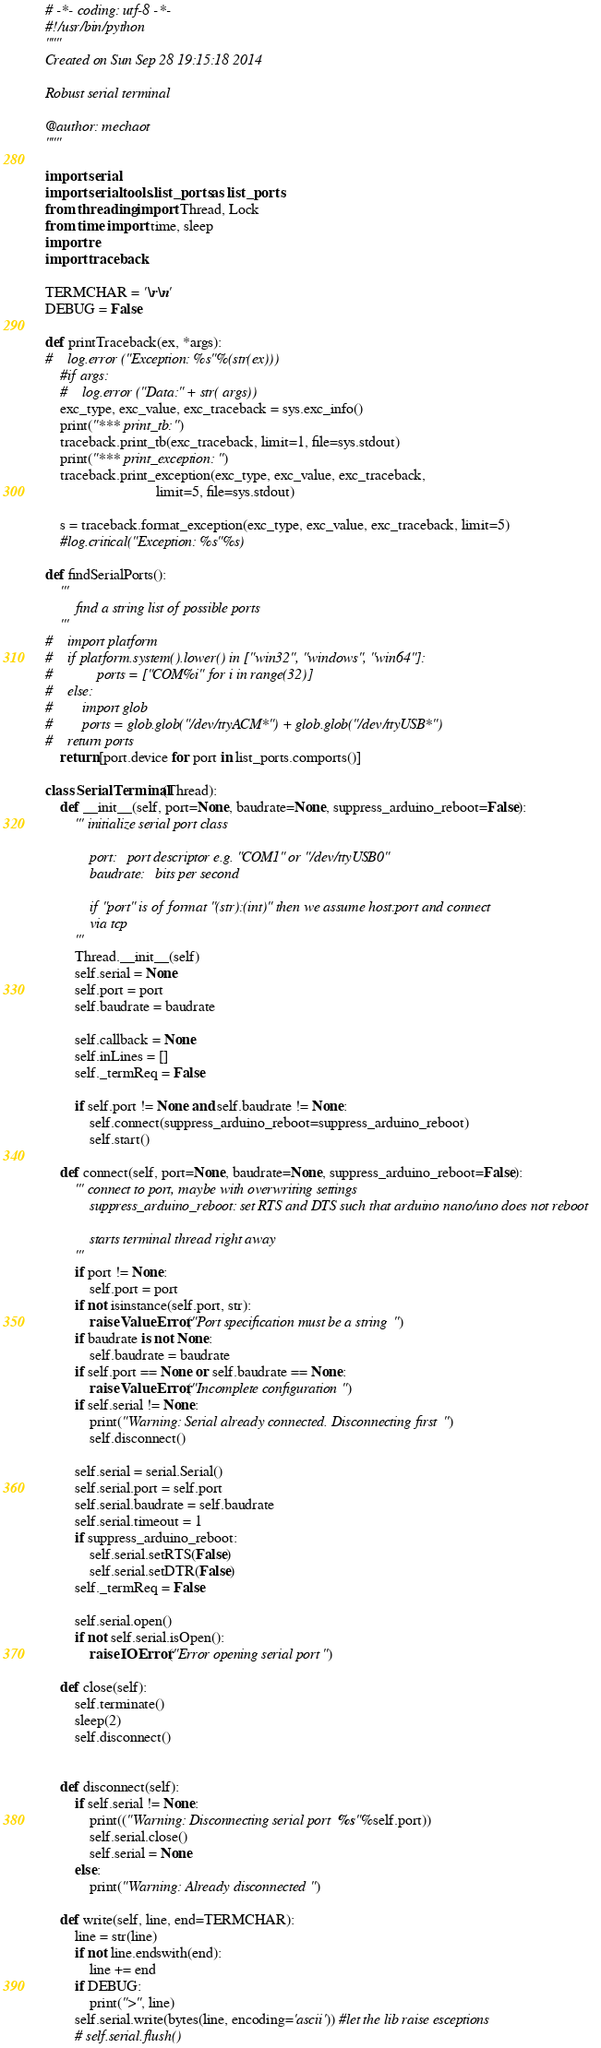Convert code to text. <code><loc_0><loc_0><loc_500><loc_500><_Python_># -*- coding: utf-8 -*-
#!/usr/bin/python
"""
Created on Sun Sep 28 19:15:18 2014

Robust serial terminal

@author: mechaot
"""

import serial
import serial.tools.list_ports as list_ports
from threading import Thread, Lock
from time import time, sleep
import re
import traceback

TERMCHAR = '\r\n'
DEBUG = False

def printTraceback(ex, *args):
#    log.error ("Exception: %s"%(str(ex)))
    #if args:
    #    log.error ("Data:" + str( args))
    exc_type, exc_value, exc_traceback = sys.exc_info()
    print("*** print_tb:")
    traceback.print_tb(exc_traceback, limit=1, file=sys.stdout)
    print("*** print_exception:")
    traceback.print_exception(exc_type, exc_value, exc_traceback,
                              limit=5, file=sys.stdout)

    s = traceback.format_exception(exc_type, exc_value, exc_traceback, limit=5)
    #log.critical("Exception: %s"%s)
    
def findSerialPorts():
    '''
        find a string list of possible ports
    '''
#    import platform
#    if platform.system().lower() in ["win32", "windows", "win64"]:
#            ports = ["COM%i" for i in range(32)]
#    else:
#        import glob
#        ports = glob.glob("/dev/ttyACM*") + glob.glob("/dev/ttyUSB*")
#    return ports
    return [port.device for port in list_ports.comports()]

class SerialTerminal(Thread):
    def __init__(self, port=None, baudrate=None, suppress_arduino_reboot=False):
        ''' initialize serial port class
        
            port:   port descriptor e.g. "COM1" or "/dev/ttyUSB0"
            baudrate:   bits per second

            if "port" is of format "(str):(int)" then we assume host:port and connect
            via tcp
        '''
        Thread.__init__(self)
        self.serial = None
        self.port = port
        self.baudrate = baudrate

        self.callback = None
        self.inLines = []
        self._termReq = False                
                
        if self.port != None and self.baudrate != None:
            self.connect(suppress_arduino_reboot=suppress_arduino_reboot)
            self.start()
        
    def connect(self, port=None, baudrate=None, suppress_arduino_reboot=False):
        ''' connect to port, maybe with overwriting settings
            suppress_arduino_reboot: set RTS and DTS such that arduino nano/uno does not reboot
            
            starts terminal thread right away
        '''
        if port != None:
            self.port = port
        if not isinstance(self.port, str):
            raise ValueError("Port specification must be a string")
        if baudrate is not None:
            self.baudrate = baudrate
        if self.port == None or self.baudrate == None:
            raise ValueError("Incomplete configuration")
        if self.serial != None:
            print("Warning: Serial already connected. Disconnecting first")
            self.disconnect()
                        
        self.serial = serial.Serial()            
        self.serial.port = self.port
        self.serial.baudrate = self.baudrate
        self.serial.timeout = 1
        if suppress_arduino_reboot:
            self.serial.setRTS(False)
            self.serial.setDTR(False)
        self._termReq = False
        
        self.serial.open()
        if not self.serial.isOpen():
            raise IOError("Error opening serial port")
        
    def close(self):
        self.terminate()
        sleep(2)
        self.disconnect()

        
    def disconnect(self):
        if self.serial != None:
            print(("Warning: Disconnecting serial port %s"%self.port))            
            self.serial.close()
            self.serial = None            
        else:
            print("Warning: Already disconnected")            
            
    def write(self, line, end=TERMCHAR):
        line = str(line)
        if not line.endswith(end):
            line += end
        if DEBUG:
            print(">", line)
        self.serial.write(bytes(line, encoding='ascii')) #let the lib raise esceptions
        # self.serial.flush()
</code> 